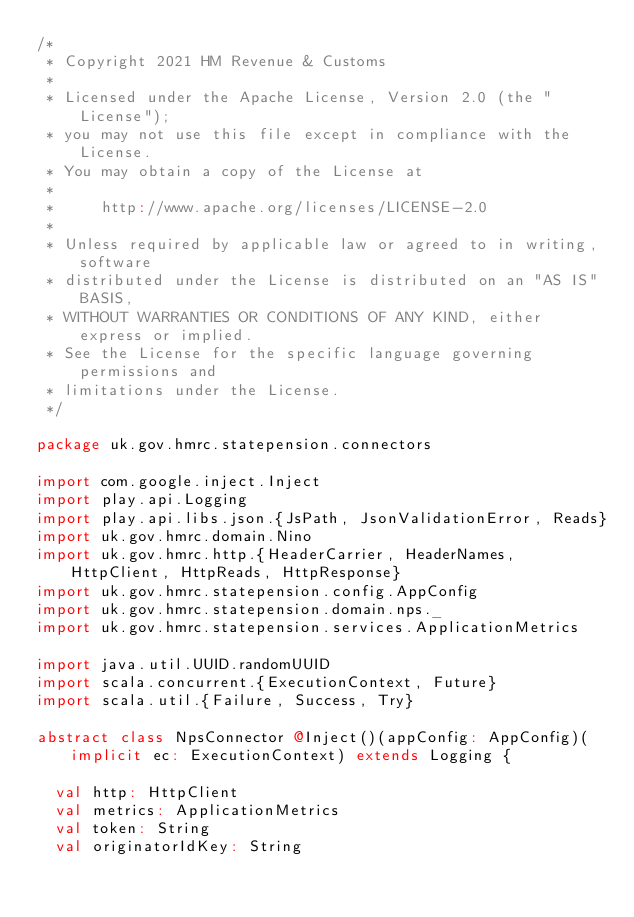<code> <loc_0><loc_0><loc_500><loc_500><_Scala_>/*
 * Copyright 2021 HM Revenue & Customs
 *
 * Licensed under the Apache License, Version 2.0 (the "License");
 * you may not use this file except in compliance with the License.
 * You may obtain a copy of the License at
 *
 *     http://www.apache.org/licenses/LICENSE-2.0
 *
 * Unless required by applicable law or agreed to in writing, software
 * distributed under the License is distributed on an "AS IS" BASIS,
 * WITHOUT WARRANTIES OR CONDITIONS OF ANY KIND, either express or implied.
 * See the License for the specific language governing permissions and
 * limitations under the License.
 */

package uk.gov.hmrc.statepension.connectors

import com.google.inject.Inject
import play.api.Logging
import play.api.libs.json.{JsPath, JsonValidationError, Reads}
import uk.gov.hmrc.domain.Nino
import uk.gov.hmrc.http.{HeaderCarrier, HeaderNames, HttpClient, HttpReads, HttpResponse}
import uk.gov.hmrc.statepension.config.AppConfig
import uk.gov.hmrc.statepension.domain.nps._
import uk.gov.hmrc.statepension.services.ApplicationMetrics

import java.util.UUID.randomUUID
import scala.concurrent.{ExecutionContext, Future}
import scala.util.{Failure, Success, Try}

abstract class NpsConnector @Inject()(appConfig: AppConfig)(implicit ec: ExecutionContext) extends Logging {

  val http: HttpClient
  val metrics: ApplicationMetrics
  val token: String
  val originatorIdKey: String</code> 